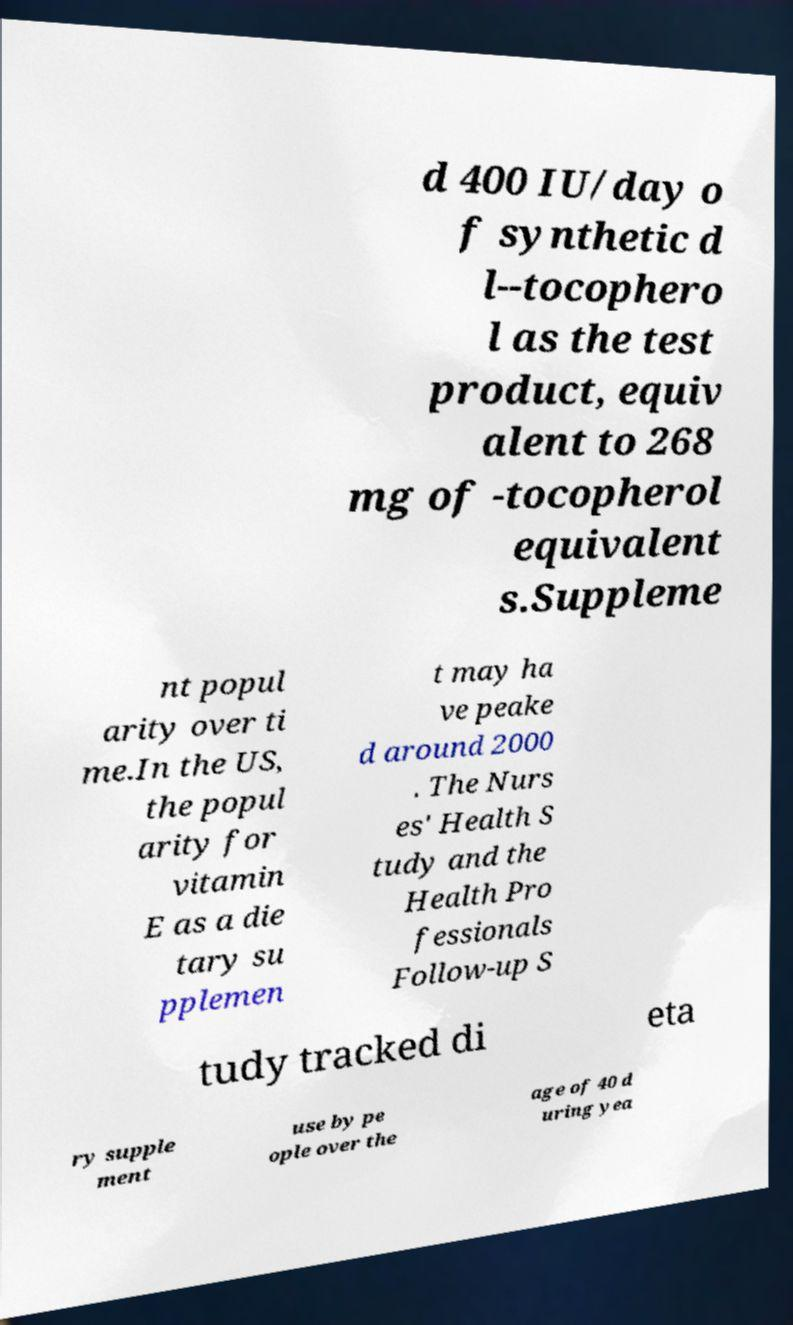Could you extract and type out the text from this image? d 400 IU/day o f synthetic d l--tocophero l as the test product, equiv alent to 268 mg of -tocopherol equivalent s.Suppleme nt popul arity over ti me.In the US, the popul arity for vitamin E as a die tary su pplemen t may ha ve peake d around 2000 . The Nurs es' Health S tudy and the Health Pro fessionals Follow-up S tudy tracked di eta ry supple ment use by pe ople over the age of 40 d uring yea 